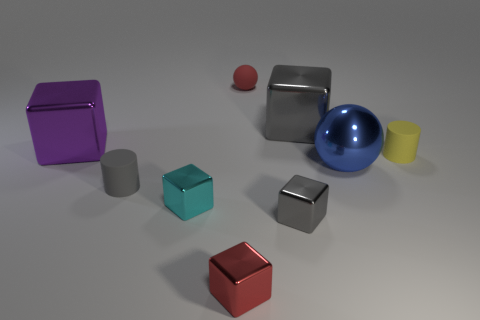Subtract 3 blocks. How many blocks are left? 2 Subtract all purple cubes. How many cubes are left? 4 Subtract all large purple metallic blocks. How many blocks are left? 4 Add 1 big gray metallic blocks. How many objects exist? 10 Subtract all purple cubes. Subtract all blue spheres. How many cubes are left? 4 Subtract all spheres. How many objects are left? 7 Add 9 tiny gray shiny blocks. How many tiny gray shiny blocks exist? 10 Subtract 0 red cylinders. How many objects are left? 9 Subtract all large green metal objects. Subtract all cyan things. How many objects are left? 8 Add 3 tiny gray metallic cubes. How many tiny gray metallic cubes are left? 4 